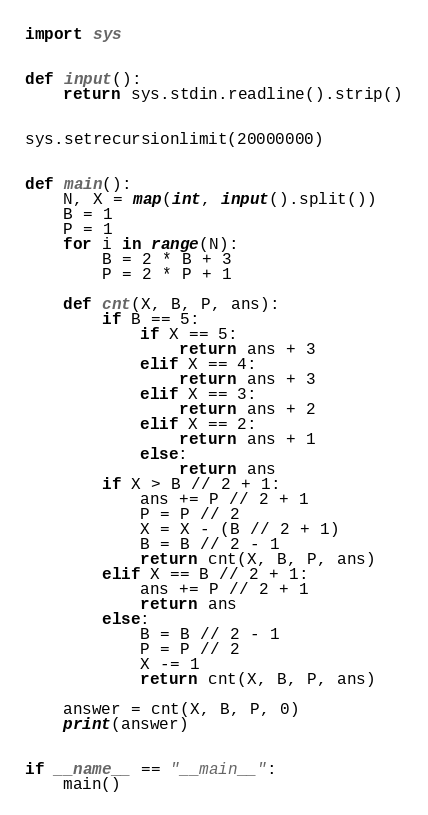Convert code to text. <code><loc_0><loc_0><loc_500><loc_500><_Python_>import sys


def input():
    return sys.stdin.readline().strip()


sys.setrecursionlimit(20000000)


def main():
    N, X = map(int, input().split())
    B = 1
    P = 1
    for i in range(N):
        B = 2 * B + 3
        P = 2 * P + 1

    def cnt(X, B, P, ans):
        if B == 5:
            if X == 5:
                return ans + 3
            elif X == 4:
                return ans + 3
            elif X == 3:
                return ans + 2
            elif X == 2:
                return ans + 1
            else:
                return ans
        if X > B // 2 + 1:
            ans += P // 2 + 1
            P = P // 2
            X = X - (B // 2 + 1)
            B = B // 2 - 1
            return cnt(X, B, P, ans)
        elif X == B // 2 + 1:
            ans += P // 2 + 1
            return ans
        else:
            B = B // 2 - 1
            P = P // 2
            X -= 1
            return cnt(X, B, P, ans)

    answer = cnt(X, B, P, 0)
    print(answer)


if __name__ == "__main__":
    main()
</code> 